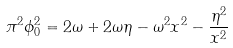Convert formula to latex. <formula><loc_0><loc_0><loc_500><loc_500>\pi ^ { 2 } \phi _ { 0 } ^ { 2 } = 2 \omega + 2 \omega \eta - \omega ^ { 2 } x ^ { 2 } - \frac { \eta ^ { 2 } } { x ^ { 2 } }</formula> 